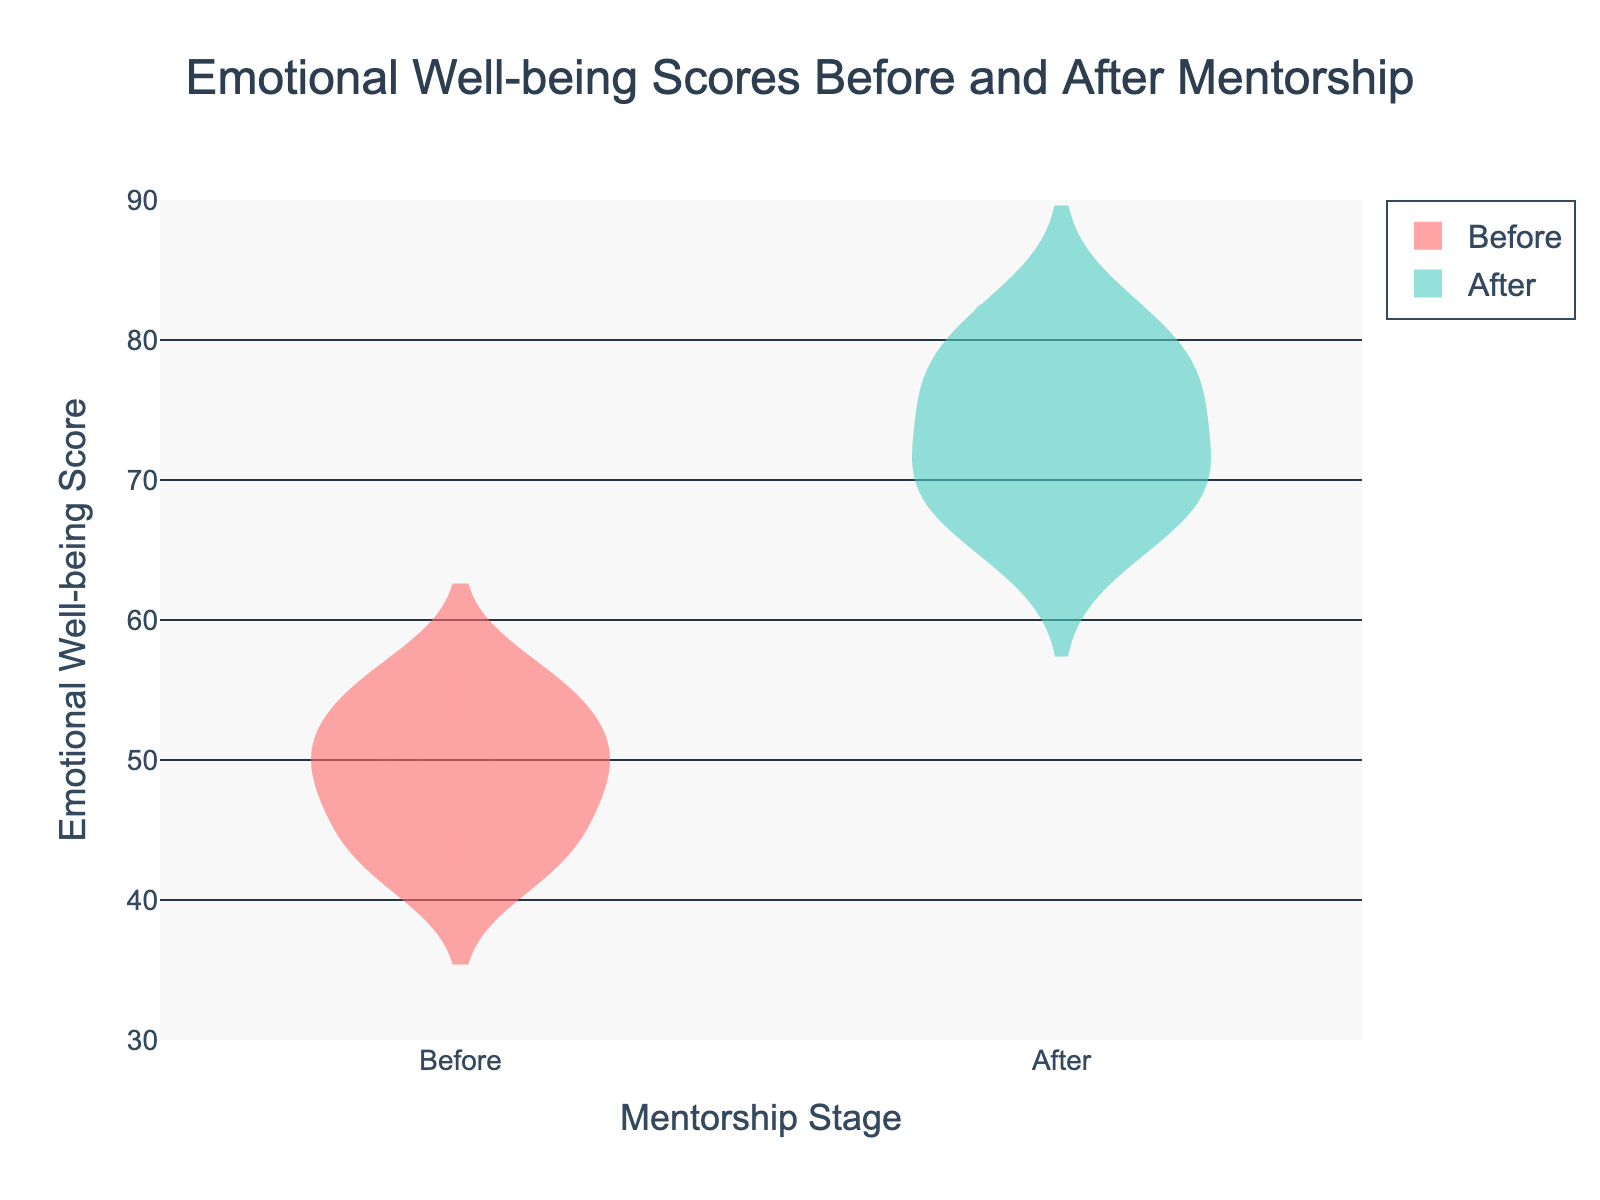What's the title of the figure? The title of the figure can be found at the top of the chart and is clearly written.
Answer: Emotional Well-being Scores Before and After Mentorship What do the colors red and green in the plot represent? Red represents the "Before" group, and green represents the "After" group as specified in the violin plot legend.
Answer: Before: red, After: green How many data points are there in each group? Each group, "Before" and "After," has corresponding data points for each child. By counting the child IDs, we can see there are 10 data points in each group.
Answer: 10 What's the range of the emotional well-being scores displayed on the y-axis? The y-axis of the figure shows scores ranging from 30 to 90.
Answer: 30 to 90 What is the mean line value for the "After" group? The mean line is visibly marked on the violin plot for the "After" group and appears around the top of the plot. This value can be approximated visually.
Answer: Approximately 74 Is there a visible difference between "Before" and "After" distributions? By visually comparing the vertical spans and the spread of the data points, one can see that the "After" group is generally higher and more concentrated around higher scores.
Answer: Yes What is the interquartile range (IQR) for the "Before" group? To determine the IQR, observe the box plot within the violin chart for the "Before" group. The IQR spans between the first quartile (Q1) and the third quartile (Q3).
Answer: Approximately 8 Which group has the highest maximum value? By visually inspecting the top of each violin plot, the "After" group reaches a higher maximum value (around 82) compared to the "Before" group (around 56).
Answer: After group Are there any outliers in the "Before" group? Looking for isolated points outside the main distribution in the "Before" violin plot can help identify outliers. No such isolated points are visible.
Answer: No Which group shows greater variation in emotional well-being scores? Variation can be noted by the spread or width of the violin plot. The "Before" group shows greater variation as the distribution is wider compared to the "After" group.
Answer: Before group 